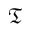<formula> <loc_0><loc_0><loc_500><loc_500>\mathfrak T</formula> 